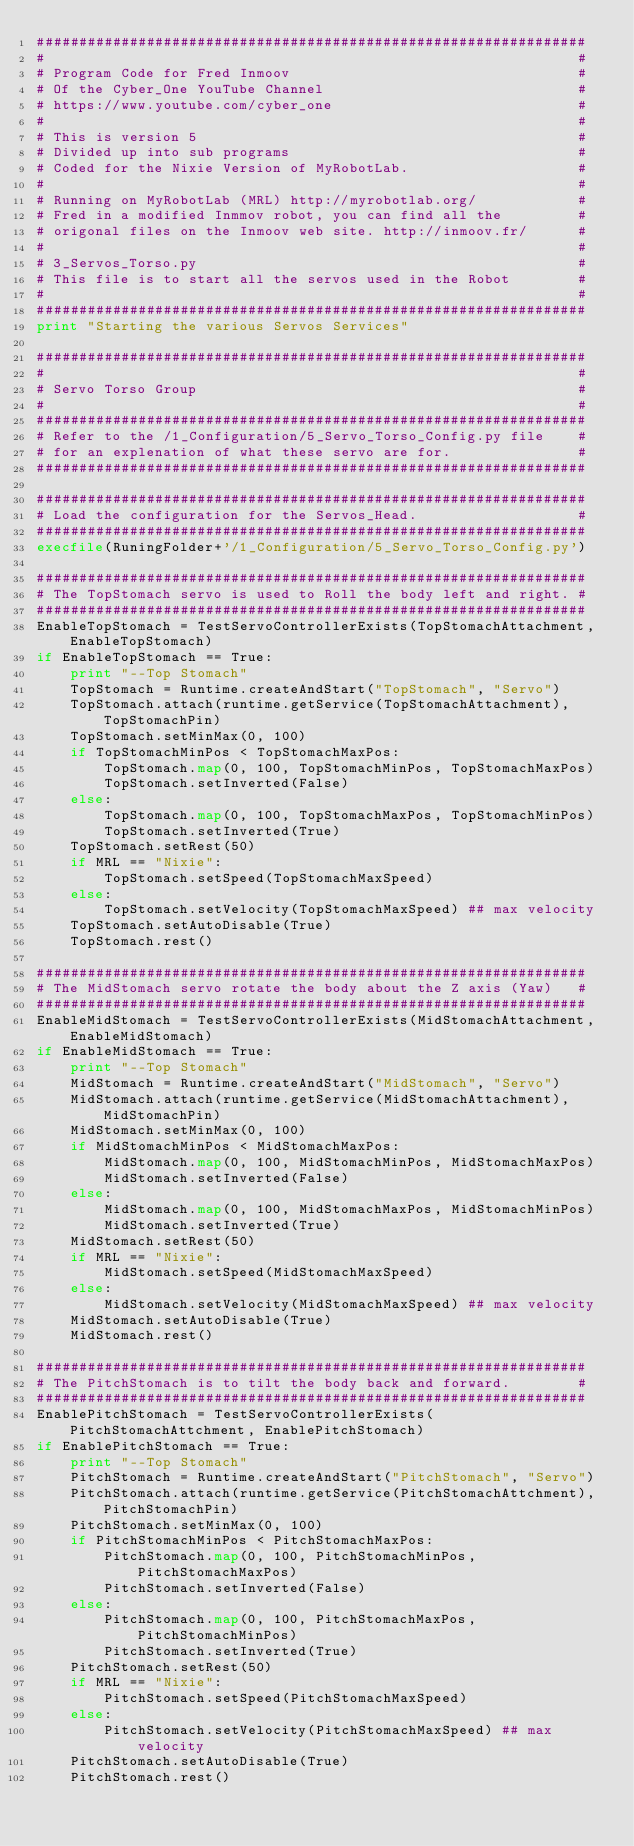<code> <loc_0><loc_0><loc_500><loc_500><_Python_>#################################################################
#                                                               #
# Program Code for Fred Inmoov                                  #
# Of the Cyber_One YouTube Channel                              #
# https://www.youtube.com/cyber_one                             #
#                                                               #
# This is version 5                                             #
# Divided up into sub programs                                  #
# Coded for the Nixie Version of MyRobotLab.                    #
#                                                               #
# Running on MyRobotLab (MRL) http://myrobotlab.org/            #
# Fred in a modified Inmmov robot, you can find all the         #
# origonal files on the Inmoov web site. http://inmoov.fr/      #
#                                                               #
# 3_Servos_Torso.py                                             #
# This file is to start all the servos used in the Robot        #
#                                                               #
#################################################################
print "Starting the various Servos Services"

#################################################################
#                                                               #
# Servo Torso Group                                             #
#                                                               #
#################################################################
# Refer to the /1_Configuration/5_Servo_Torso_Config.py file    #
# for an explenation of what these servo are for.               #
#################################################################

#################################################################
# Load the configuration for the Servos_Head.                   #
#################################################################
execfile(RuningFolder+'/1_Configuration/5_Servo_Torso_Config.py')

#################################################################
# The TopStomach servo is used to Roll the body left and right. #
#################################################################
EnableTopStomach = TestServoControllerExists(TopStomachAttachment, EnableTopStomach)
if EnableTopStomach == True:
    print "--Top Stomach"
    TopStomach = Runtime.createAndStart("TopStomach", "Servo")
    TopStomach.attach(runtime.getService(TopStomachAttachment), TopStomachPin)
    TopStomach.setMinMax(0, 100)
    if TopStomachMinPos < TopStomachMaxPos:
        TopStomach.map(0, 100, TopStomachMinPos, TopStomachMaxPos)
        TopStomach.setInverted(False)
    else:
        TopStomach.map(0, 100, TopStomachMaxPos, TopStomachMinPos)
        TopStomach.setInverted(True)
    TopStomach.setRest(50)
    if MRL == "Nixie":
        TopStomach.setSpeed(TopStomachMaxSpeed)
    else:
        TopStomach.setVelocity(TopStomachMaxSpeed) ## max velocity
    TopStomach.setAutoDisable(True)
    TopStomach.rest()

#################################################################
# The MidStomach servo rotate the body about the Z axis (Yaw)   #
#################################################################
EnableMidStomach = TestServoControllerExists(MidStomachAttachment, EnableMidStomach)
if EnableMidStomach == True:
    print "--Top Stomach"
    MidStomach = Runtime.createAndStart("MidStomach", "Servo")
    MidStomach.attach(runtime.getService(MidStomachAttachment), MidStomachPin)
    MidStomach.setMinMax(0, 100)
    if MidStomachMinPos < MidStomachMaxPos:
        MidStomach.map(0, 100, MidStomachMinPos, MidStomachMaxPos)
        MidStomach.setInverted(False)
    else:
        MidStomach.map(0, 100, MidStomachMaxPos, MidStomachMinPos)
        MidStomach.setInverted(True)
    MidStomach.setRest(50)
    if MRL == "Nixie":
        MidStomach.setSpeed(MidStomachMaxSpeed)
    else:
        MidStomach.setVelocity(MidStomachMaxSpeed) ## max velocity
    MidStomach.setAutoDisable(True)
    MidStomach.rest()

#################################################################
# The PitchStomach is to tilt the body back and forward.        #
#################################################################
EnablePitchStomach = TestServoControllerExists(PitchStomachAttchment, EnablePitchStomach)
if EnablePitchStomach == True:
    print "--Top Stomach"
    PitchStomach = Runtime.createAndStart("PitchStomach", "Servo")
    PitchStomach.attach(runtime.getService(PitchStomachAttchment), PitchStomachPin)
    PitchStomach.setMinMax(0, 100)
    if PitchStomachMinPos < PitchStomachMaxPos:
        PitchStomach.map(0, 100, PitchStomachMinPos, PitchStomachMaxPos)
        PitchStomach.setInverted(False)
    else:
        PitchStomach.map(0, 100, PitchStomachMaxPos, PitchStomachMinPos)
        PitchStomach.setInverted(True)
    PitchStomach.setRest(50)
    if MRL == "Nixie":
        PitchStomach.setSpeed(PitchStomachMaxSpeed)
    else:
        PitchStomach.setVelocity(PitchStomachMaxSpeed) ## max velocity
    PitchStomach.setAutoDisable(True)
    PitchStomach.rest()
</code> 